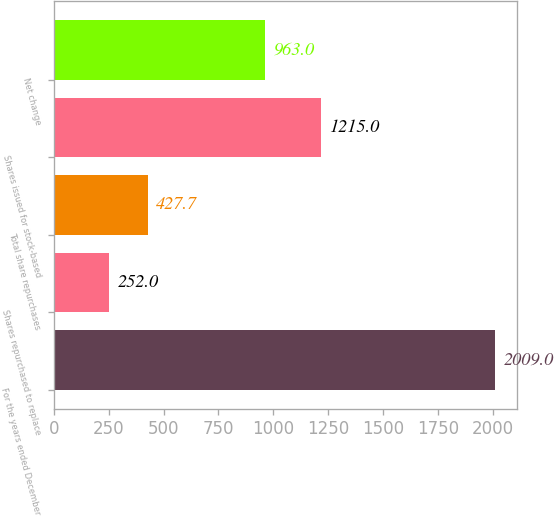Convert chart to OTSL. <chart><loc_0><loc_0><loc_500><loc_500><bar_chart><fcel>For the years ended December<fcel>Shares repurchased to replace<fcel>Total share repurchases<fcel>Shares issued for stock-based<fcel>Net change<nl><fcel>2009<fcel>252<fcel>427.7<fcel>1215<fcel>963<nl></chart> 